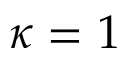Convert formula to latex. <formula><loc_0><loc_0><loc_500><loc_500>\kappa = 1</formula> 